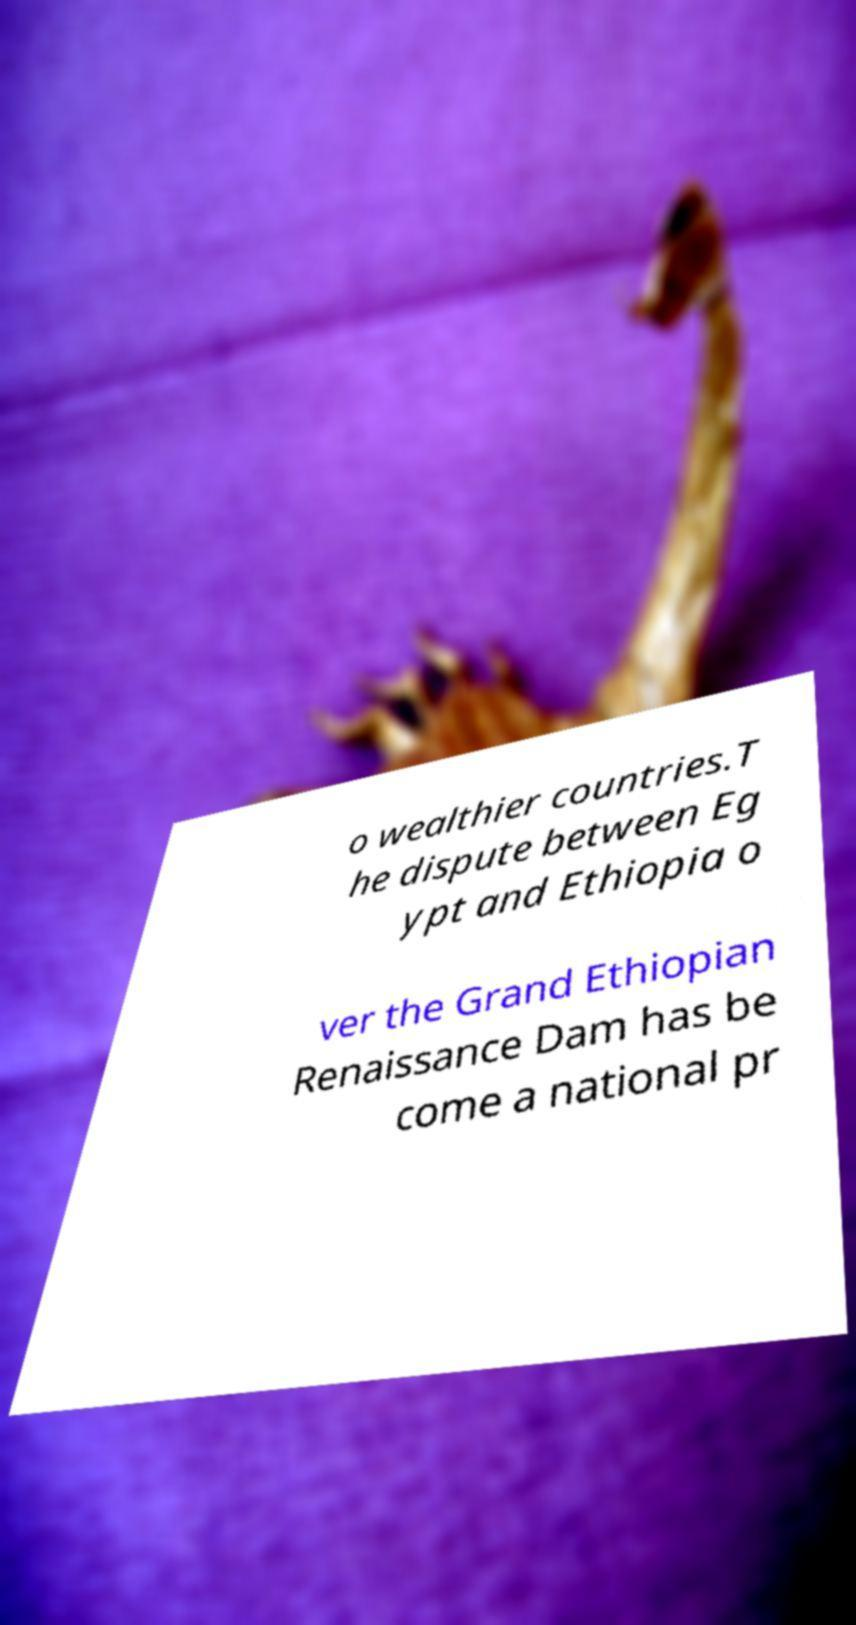For documentation purposes, I need the text within this image transcribed. Could you provide that? o wealthier countries.T he dispute between Eg ypt and Ethiopia o ver the Grand Ethiopian Renaissance Dam has be come a national pr 